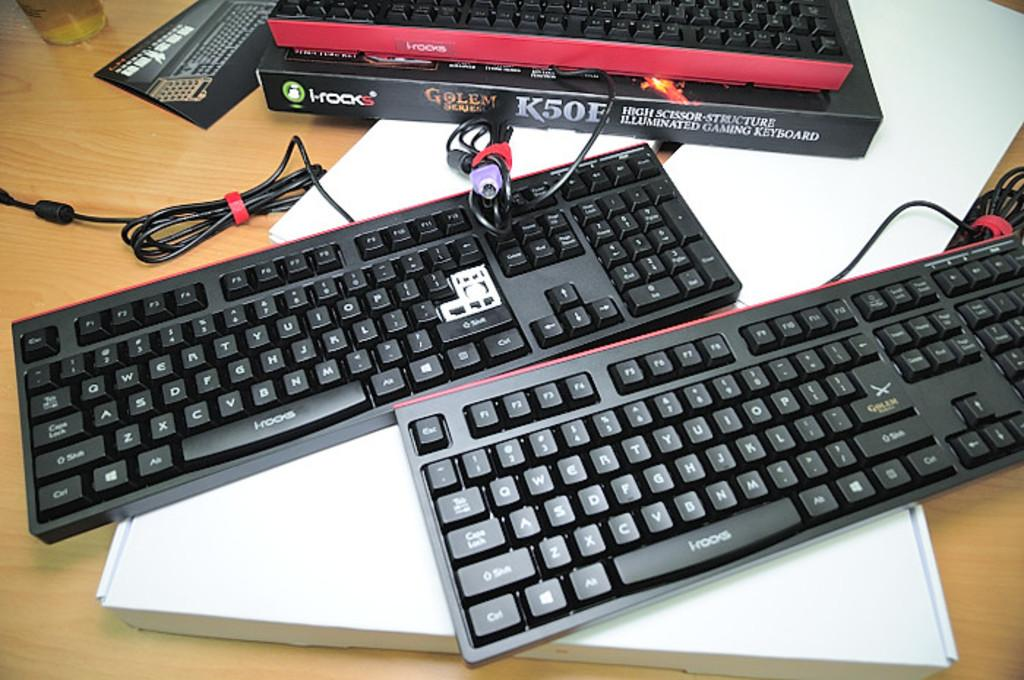<image>
Share a concise interpretation of the image provided. Two keyboards sit below a black K50E box. 